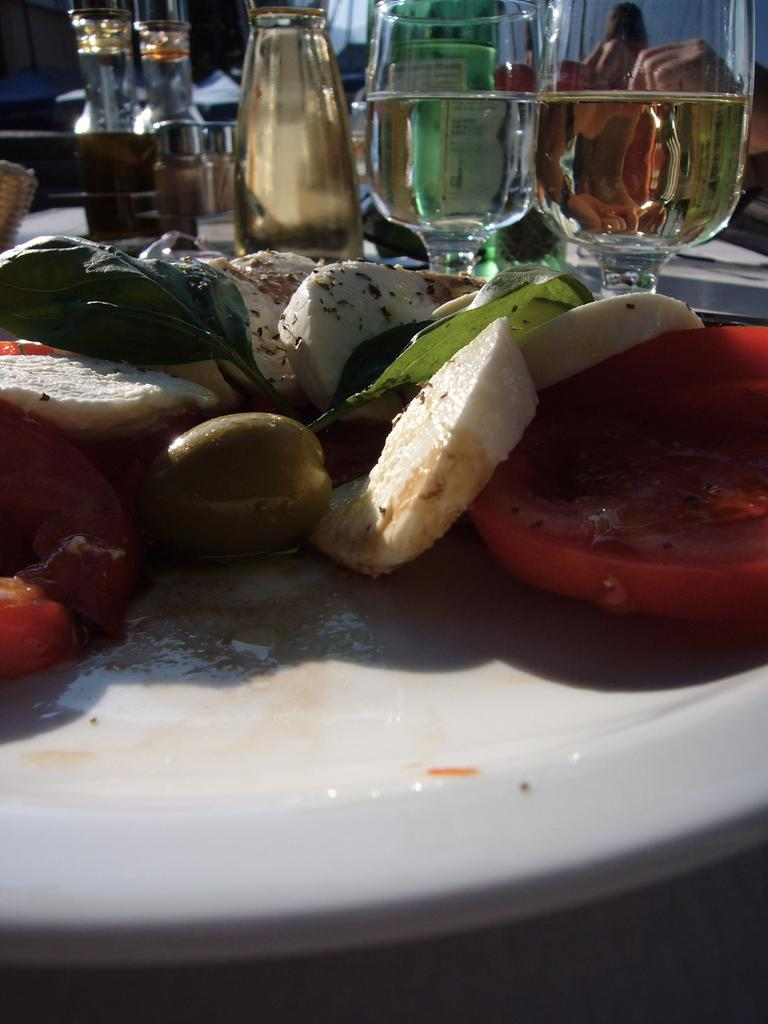What is on the plate in the image? There is food placed on a plate in the image. What type of beverage is in the wine glasses? The wine glasses are filled with wine in the image. Can you describe the food on the plate? The food includes tomato, slices, olives, cheese, and green leaves. What type of friction can be seen between the tomato and the cheese in the image? There is no friction between the tomato and the cheese in the image, as they are not interacting in a way that would cause friction. 